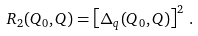<formula> <loc_0><loc_0><loc_500><loc_500>R _ { 2 } ( Q _ { 0 } , Q ) = \left [ \Delta _ { q } ( Q _ { 0 } , Q ) \right ] ^ { 2 } \, .</formula> 